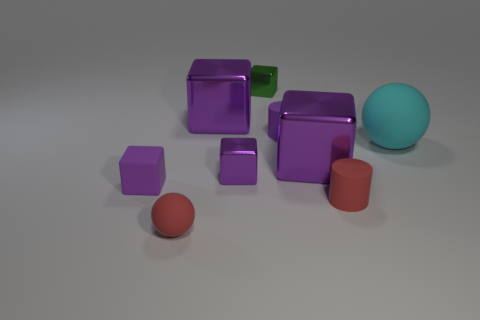Subtract all cyan cylinders. How many purple blocks are left? 4 Subtract all green cubes. How many cubes are left? 4 Subtract all rubber cubes. How many cubes are left? 4 Subtract all brown blocks. Subtract all green cylinders. How many blocks are left? 5 Add 1 purple blocks. How many objects exist? 10 Subtract all cylinders. How many objects are left? 7 Add 7 cyan rubber things. How many cyan rubber things exist? 8 Subtract 0 yellow cubes. How many objects are left? 9 Subtract all tiny cyan matte cylinders. Subtract all purple cylinders. How many objects are left? 8 Add 4 cylinders. How many cylinders are left? 6 